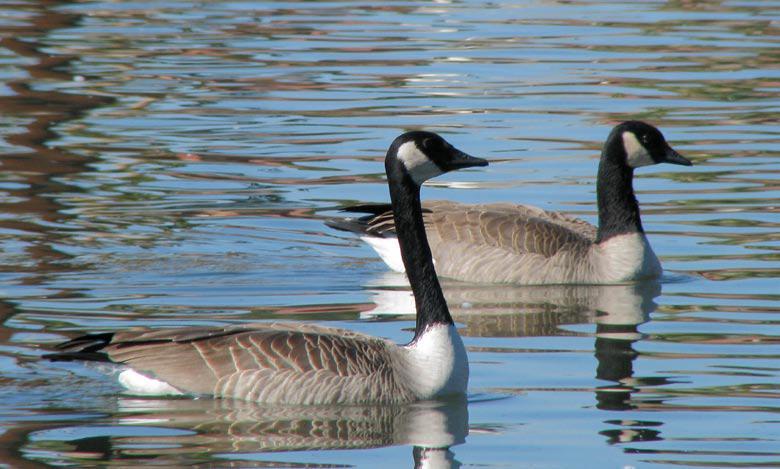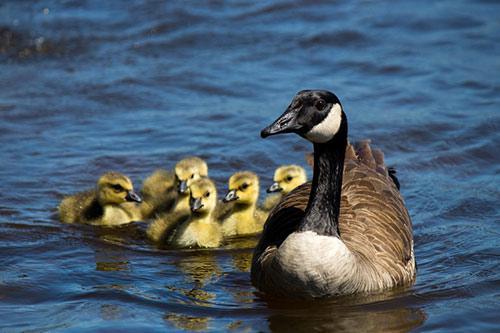The first image is the image on the left, the second image is the image on the right. Considering the images on both sides, is "The left image contains exactly two ducks both swimming in the same direction." valid? Answer yes or no. Yes. The first image is the image on the left, the second image is the image on the right. Given the left and right images, does the statement "An image shows exactly two black-necked geese on water, both heading rightward." hold true? Answer yes or no. Yes. 